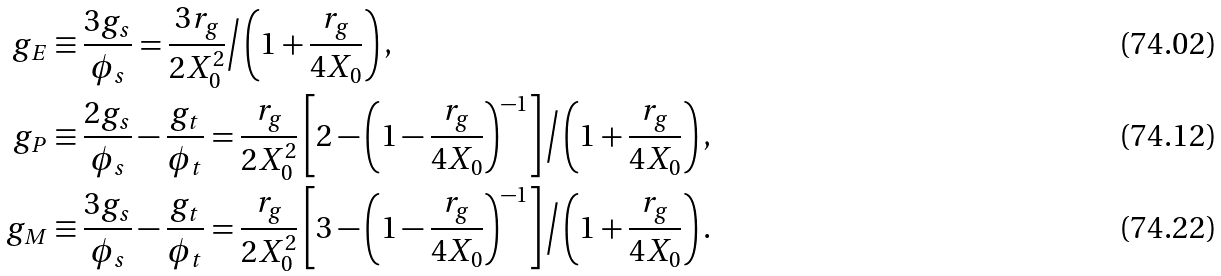Convert formula to latex. <formula><loc_0><loc_0><loc_500><loc_500>g _ { E } & \equiv \frac { 3 g _ { s } } { \phi _ { s } } = \frac { 3 r _ { g } } { 2 X _ { 0 } ^ { 2 } } \Big / \left ( 1 + \frac { r _ { g } } { 4 X _ { 0 } } \right ) , \\ g _ { P } & \equiv \frac { 2 g _ { s } } { \phi _ { s } } - \frac { g _ { t } } { \phi _ { t } } = \frac { r _ { g } } { 2 X _ { 0 } ^ { 2 } } \left [ 2 - \left ( 1 - \frac { r _ { g } } { 4 X _ { 0 } } \right ) ^ { - 1 } \right ] \Big / \left ( 1 + \frac { r _ { g } } { 4 X _ { 0 } } \right ) , \\ g _ { M } & \equiv \frac { 3 g _ { s } } { \phi _ { s } } - \frac { g _ { t } } { \phi _ { t } } = \frac { r _ { g } } { 2 X _ { 0 } ^ { 2 } } \left [ 3 - \left ( 1 - \frac { r _ { g } } { 4 X _ { 0 } } \right ) ^ { - 1 } \right ] \Big / \left ( 1 + \frac { r _ { g } } { 4 X _ { 0 } } \right ) .</formula> 